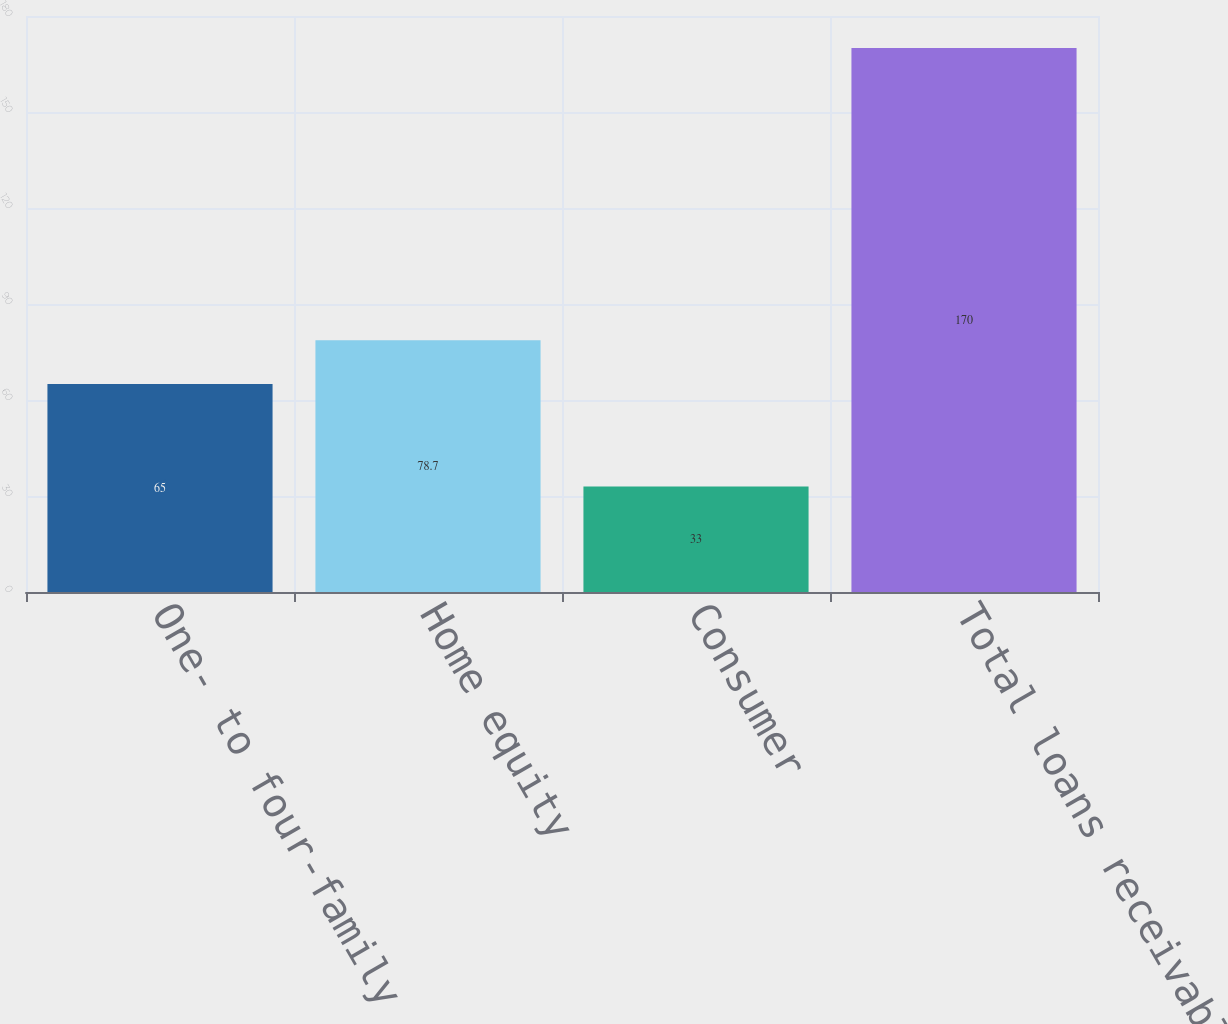Convert chart. <chart><loc_0><loc_0><loc_500><loc_500><bar_chart><fcel>One- to four-family<fcel>Home equity<fcel>Consumer<fcel>Total loans receivable<nl><fcel>65<fcel>78.7<fcel>33<fcel>170<nl></chart> 